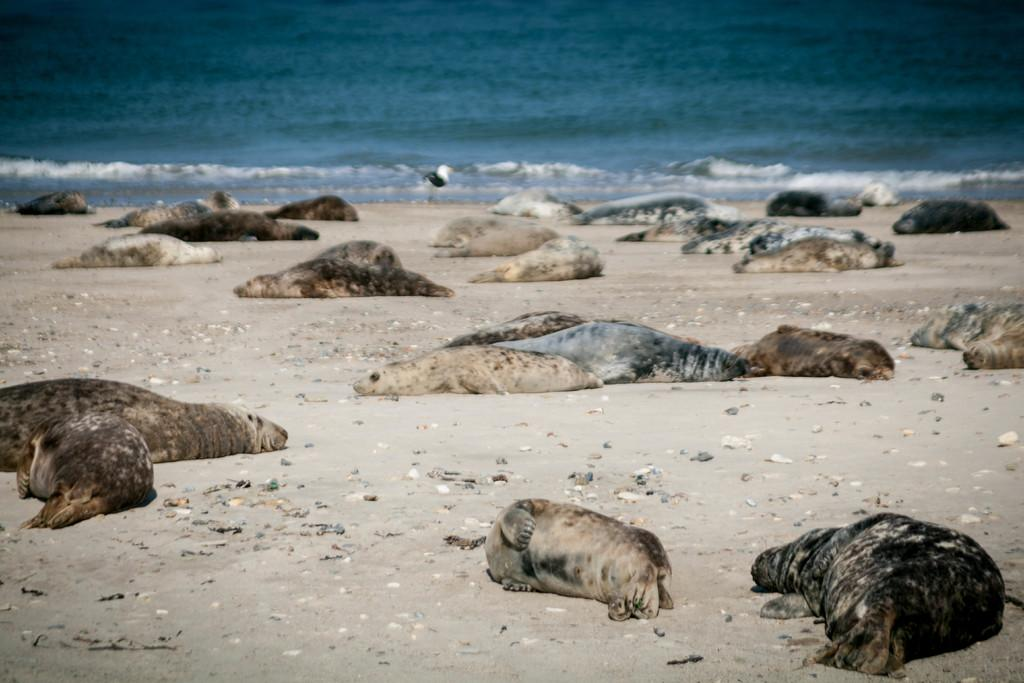What animals are in the foreground of the image? There are earless seals in the foreground of the image. What is the seals' position on the sand? The seals are lying on the sand. What can be seen in the background of the image? There is water visible in the background of the image. What type of beds can be seen in the image? There are no beds present in the image; it features earless seals lying on the sand. Can you tell me the name of the judge in the image? There is no judge present in the image; it features earless seals lying on the sand. 